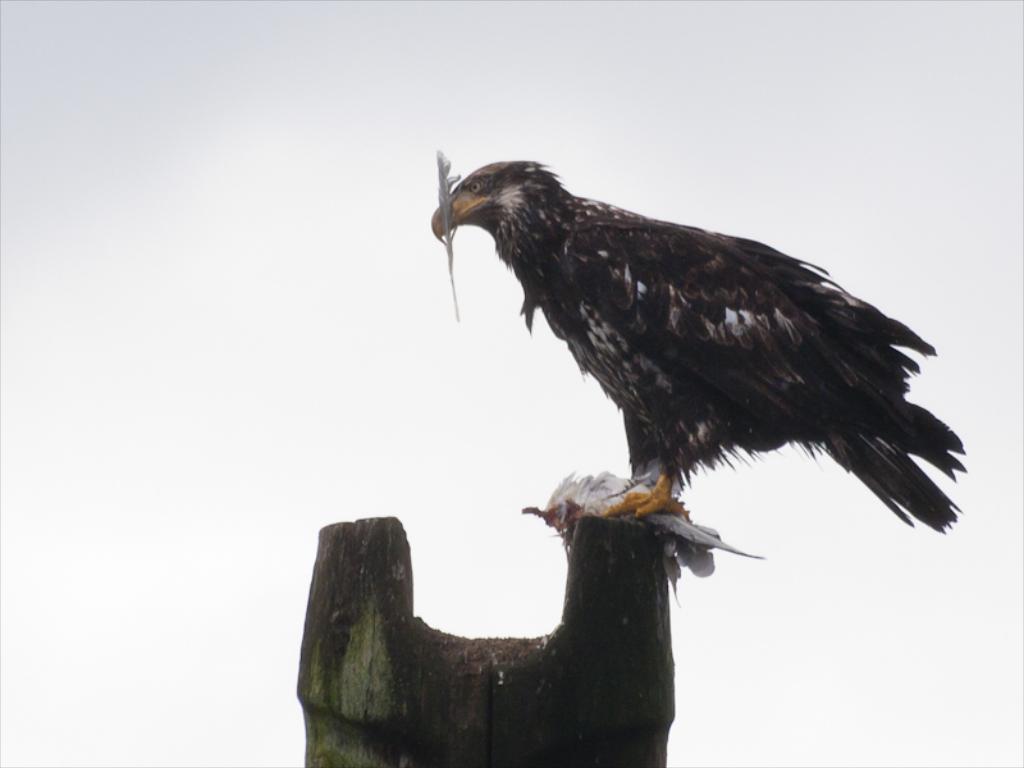Please provide a concise description of this image. In this picture we can see an Eagle standing on a wooden object. 